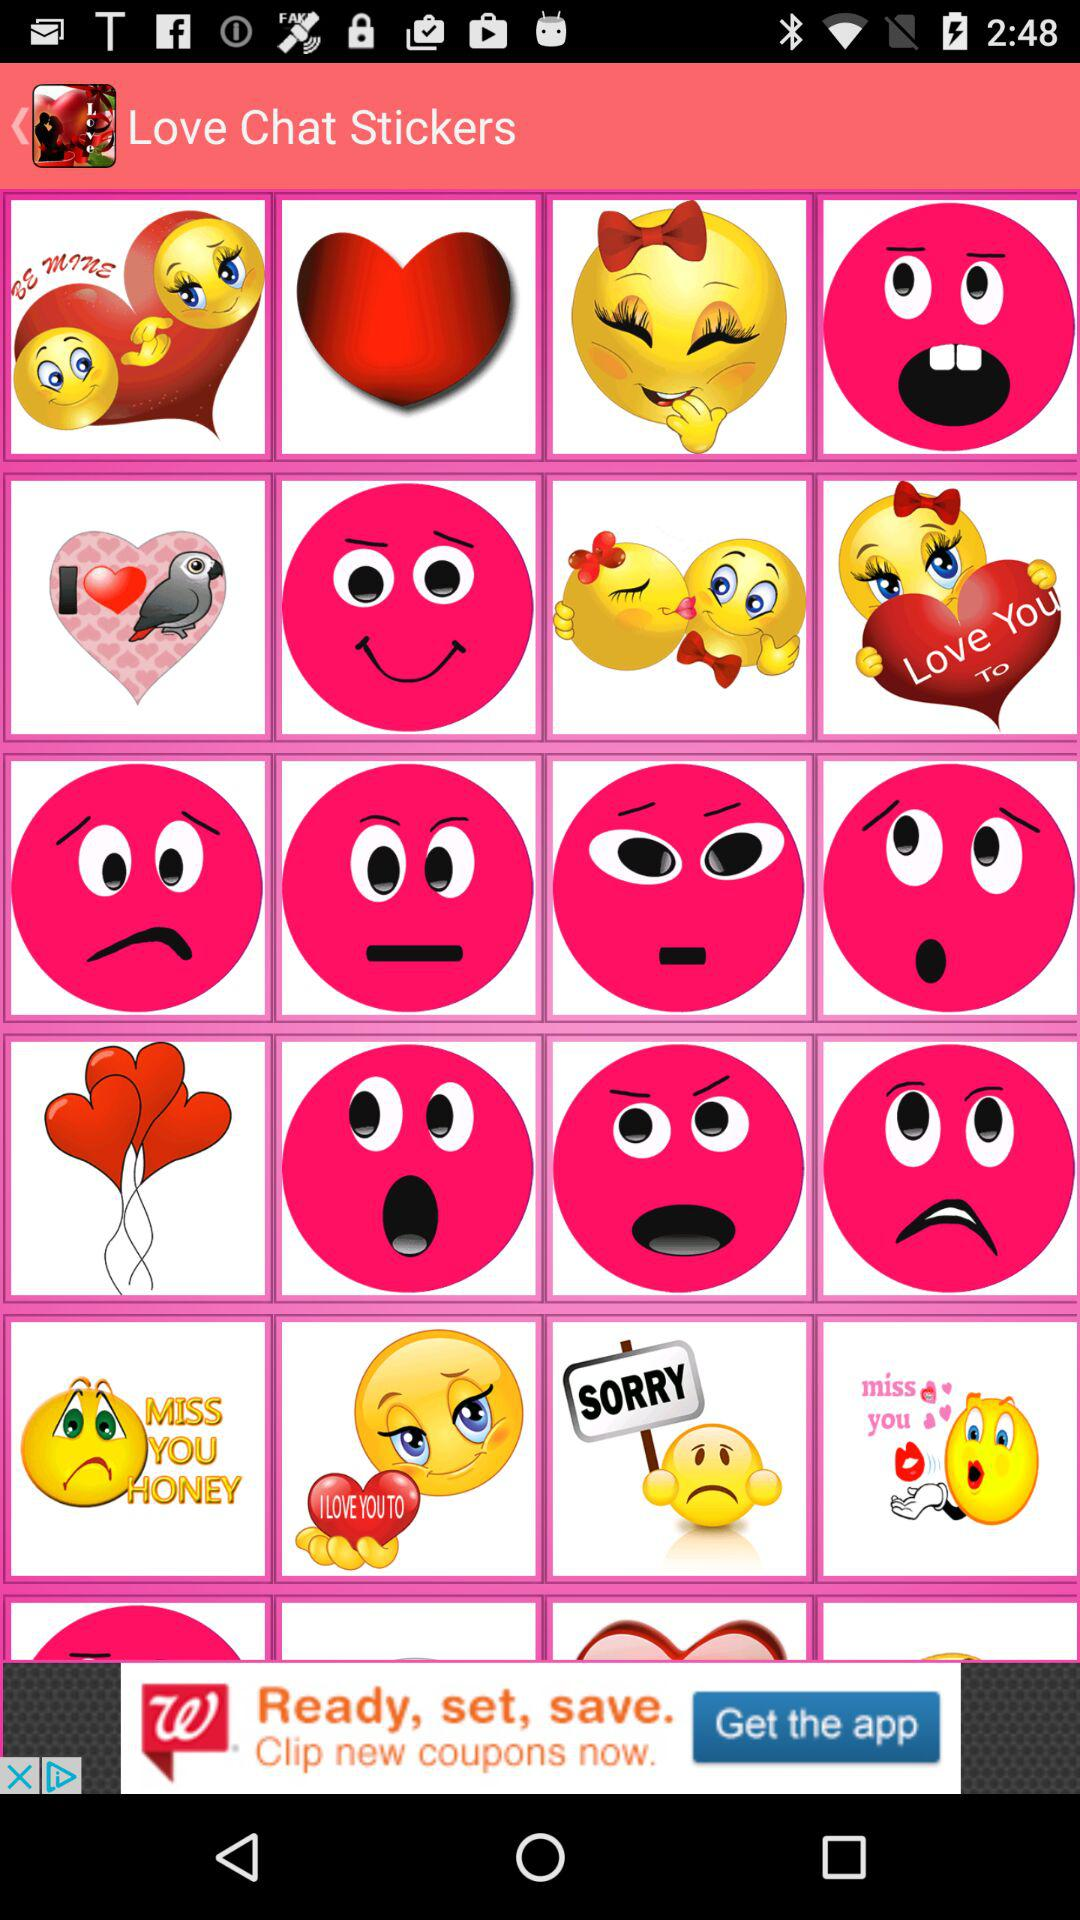What is the name of the application? The name of the application is "Love Chat Stickers". 